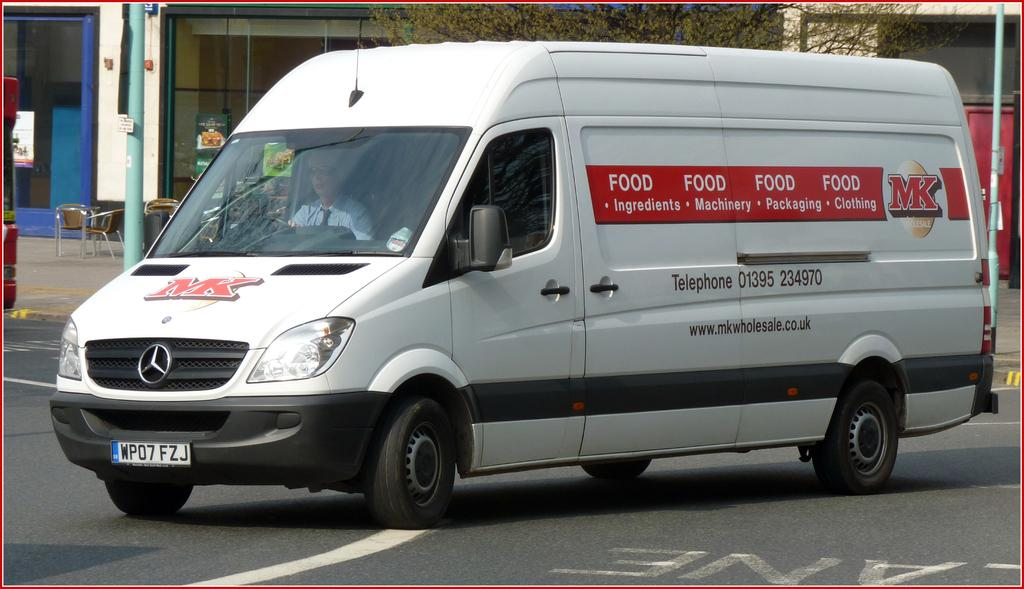What type of vehicle is in the image? There is a vehicle in the image, but the specific type is not mentioned. What color is the vehicle? The vehicle is white. What structures can be seen in the image? There are buildings visible in the image. What type of window is present in the image? There is a glass window in the image. What type of furniture is in the image? Chairs are present in the image. What vertical object is in the image? There is a pole in the image. What type of vegetation is visible in the image? Trees are visible in the image. What type of hospital can be seen in the image? There is no hospital present in the image. What tool is the woman using in the image? There is no woman or hammer present in the image. 